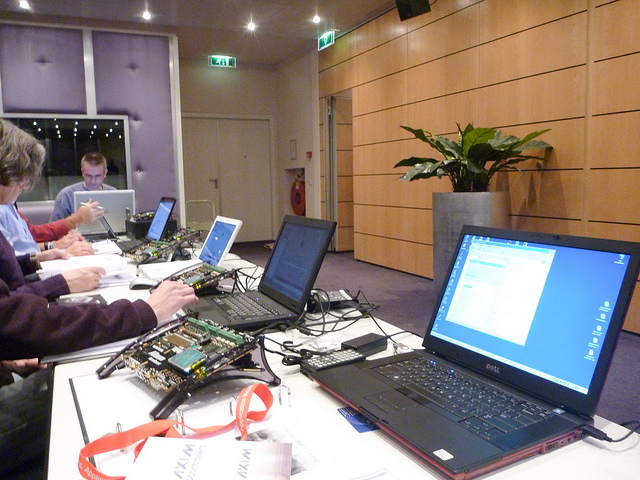Read and extract the text from this image. DELL AXIM AXIM 